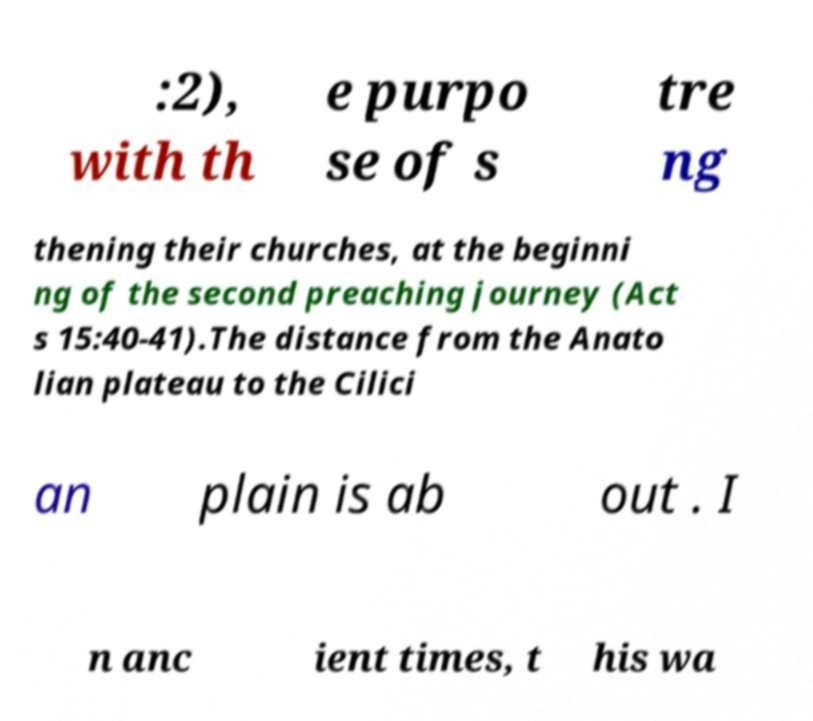Could you assist in decoding the text presented in this image and type it out clearly? :2), with th e purpo se of s tre ng thening their churches, at the beginni ng of the second preaching journey (Act s 15:40-41).The distance from the Anato lian plateau to the Cilici an plain is ab out . I n anc ient times, t his wa 